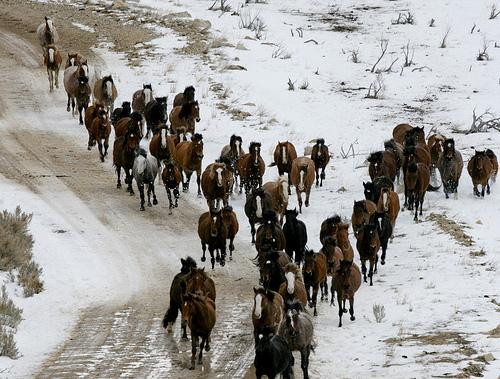What are the main activities that the horses are engaged in? List at least three. The main activities the horses are engaged in are running, stampeding, and walking. Are there any signs of human-made objects or structures in the image? No, there are no human-made objects or structures visible in the image. What are the horses' reactions or emotions portrayed in the image? The horses appear to be in motion, possibly running or moving quickly, which could suggest urgency or a response to being driven or herded. How many horses are mentioned in the image descriptions? There are many horses in the image, but a specific count isn't provided in the description. Describe the overall mood or sentiment conveyed by the image. The image conveys a sense of wild freedom, energy, and natural beauty as the horses run together through the snowy landscape. Identify if there are any distinguished horses in the group, include their physical characteristics. There are several distinguished horses, including a grey horse and a dark horse with a white face spot among others. Based on the descriptions, can you identify the role or significance of a specific horse in the herd? The leader of the herd isn't explicitly mentioned, but there is a light-colored horse at the rear of the group and horses following their leader can be inferred from the descriptions. Describe the condition of the ground and any objects found on it. The ground is covered in snow, with a muddy path worn by horse hooves, dead branches, and scrubby bushes. What color is the horse that is different from the other horses and what is it doing? The grey horse is running with brown horses. What type of landscape is depicted in the image? The image portrays a snow-covered landscape with horses, bushes, and dead branches. 